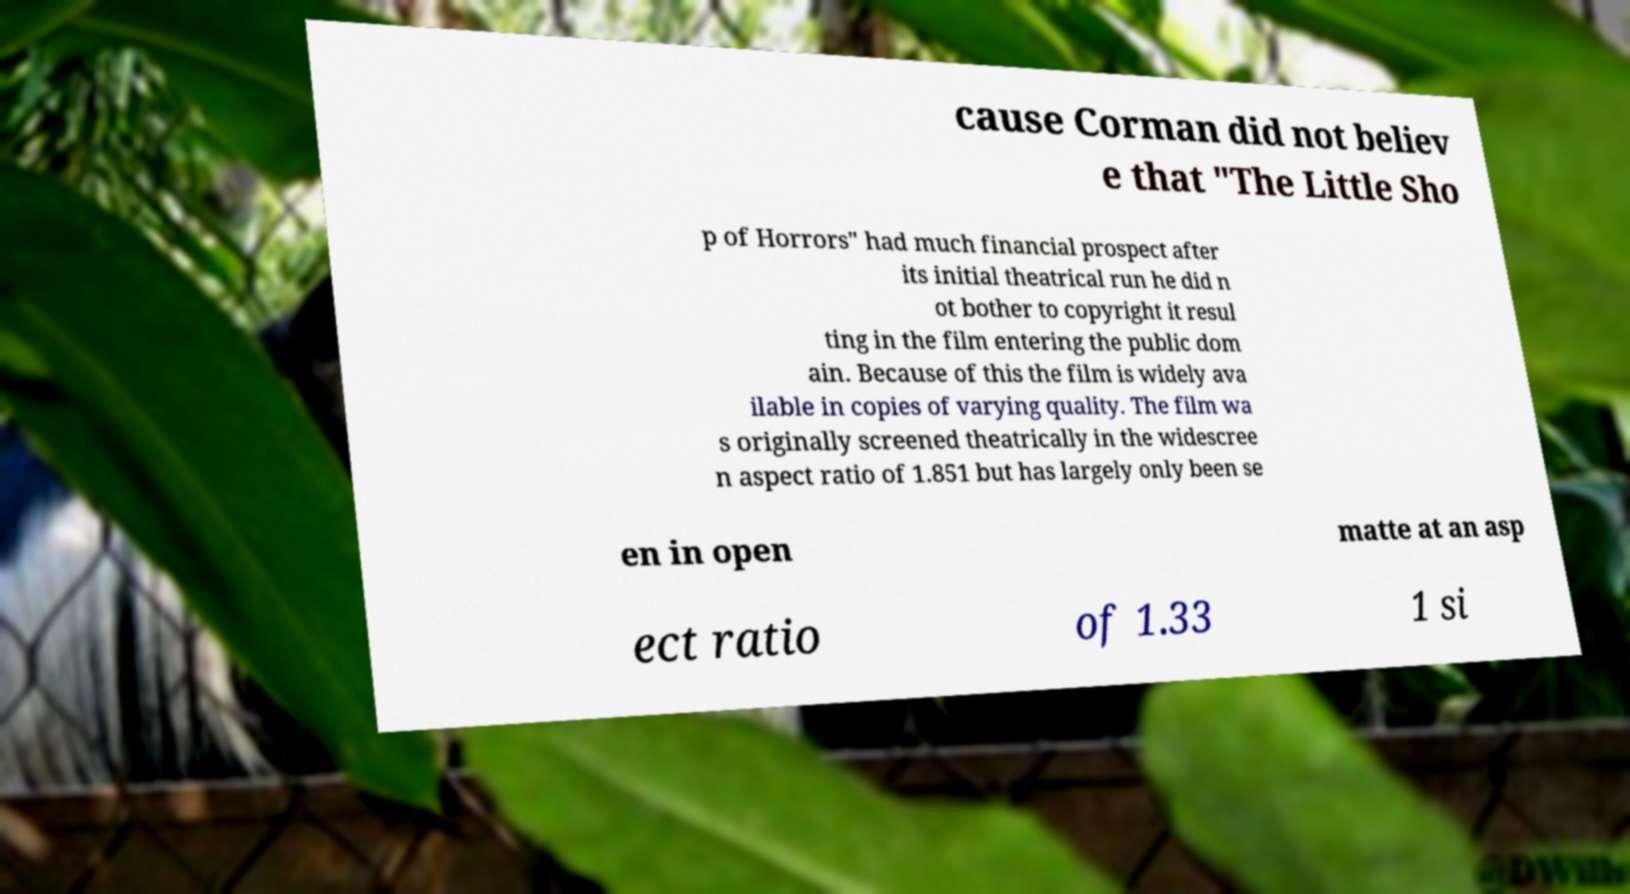Could you extract and type out the text from this image? cause Corman did not believ e that "The Little Sho p of Horrors" had much financial prospect after its initial theatrical run he did n ot bother to copyright it resul ting in the film entering the public dom ain. Because of this the film is widely ava ilable in copies of varying quality. The film wa s originally screened theatrically in the widescree n aspect ratio of 1.851 but has largely only been se en in open matte at an asp ect ratio of 1.33 1 si 